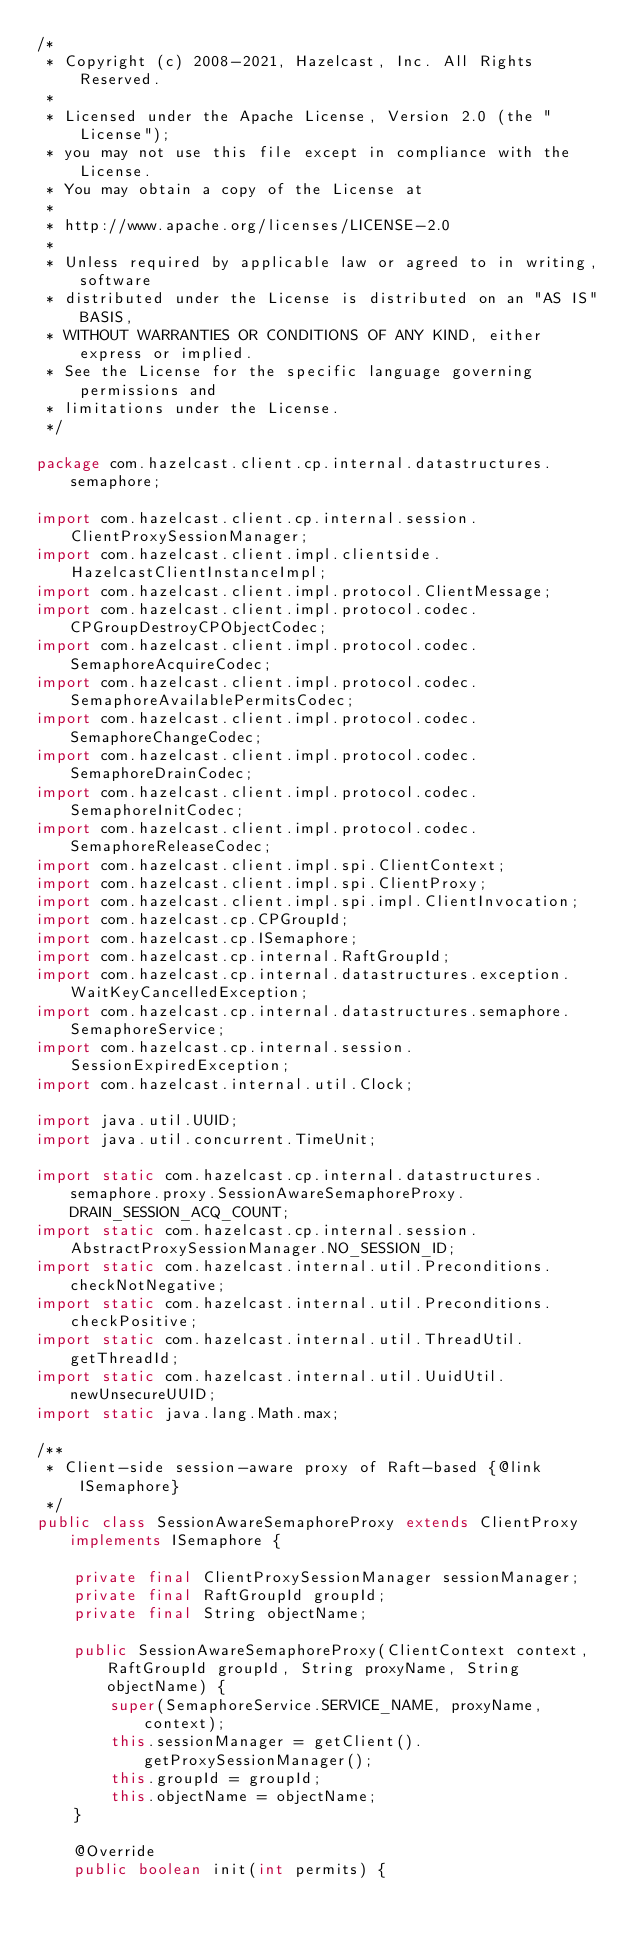<code> <loc_0><loc_0><loc_500><loc_500><_Java_>/*
 * Copyright (c) 2008-2021, Hazelcast, Inc. All Rights Reserved.
 *
 * Licensed under the Apache License, Version 2.0 (the "License");
 * you may not use this file except in compliance with the License.
 * You may obtain a copy of the License at
 *
 * http://www.apache.org/licenses/LICENSE-2.0
 *
 * Unless required by applicable law or agreed to in writing, software
 * distributed under the License is distributed on an "AS IS" BASIS,
 * WITHOUT WARRANTIES OR CONDITIONS OF ANY KIND, either express or implied.
 * See the License for the specific language governing permissions and
 * limitations under the License.
 */

package com.hazelcast.client.cp.internal.datastructures.semaphore;

import com.hazelcast.client.cp.internal.session.ClientProxySessionManager;
import com.hazelcast.client.impl.clientside.HazelcastClientInstanceImpl;
import com.hazelcast.client.impl.protocol.ClientMessage;
import com.hazelcast.client.impl.protocol.codec.CPGroupDestroyCPObjectCodec;
import com.hazelcast.client.impl.protocol.codec.SemaphoreAcquireCodec;
import com.hazelcast.client.impl.protocol.codec.SemaphoreAvailablePermitsCodec;
import com.hazelcast.client.impl.protocol.codec.SemaphoreChangeCodec;
import com.hazelcast.client.impl.protocol.codec.SemaphoreDrainCodec;
import com.hazelcast.client.impl.protocol.codec.SemaphoreInitCodec;
import com.hazelcast.client.impl.protocol.codec.SemaphoreReleaseCodec;
import com.hazelcast.client.impl.spi.ClientContext;
import com.hazelcast.client.impl.spi.ClientProxy;
import com.hazelcast.client.impl.spi.impl.ClientInvocation;
import com.hazelcast.cp.CPGroupId;
import com.hazelcast.cp.ISemaphore;
import com.hazelcast.cp.internal.RaftGroupId;
import com.hazelcast.cp.internal.datastructures.exception.WaitKeyCancelledException;
import com.hazelcast.cp.internal.datastructures.semaphore.SemaphoreService;
import com.hazelcast.cp.internal.session.SessionExpiredException;
import com.hazelcast.internal.util.Clock;

import java.util.UUID;
import java.util.concurrent.TimeUnit;

import static com.hazelcast.cp.internal.datastructures.semaphore.proxy.SessionAwareSemaphoreProxy.DRAIN_SESSION_ACQ_COUNT;
import static com.hazelcast.cp.internal.session.AbstractProxySessionManager.NO_SESSION_ID;
import static com.hazelcast.internal.util.Preconditions.checkNotNegative;
import static com.hazelcast.internal.util.Preconditions.checkPositive;
import static com.hazelcast.internal.util.ThreadUtil.getThreadId;
import static com.hazelcast.internal.util.UuidUtil.newUnsecureUUID;
import static java.lang.Math.max;

/**
 * Client-side session-aware proxy of Raft-based {@link ISemaphore}
 */
public class SessionAwareSemaphoreProxy extends ClientProxy implements ISemaphore {

    private final ClientProxySessionManager sessionManager;
    private final RaftGroupId groupId;
    private final String objectName;

    public SessionAwareSemaphoreProxy(ClientContext context, RaftGroupId groupId, String proxyName, String objectName) {
        super(SemaphoreService.SERVICE_NAME, proxyName, context);
        this.sessionManager = getClient().getProxySessionManager();
        this.groupId = groupId;
        this.objectName = objectName;
    }

    @Override
    public boolean init(int permits) {</code> 